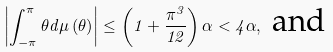Convert formula to latex. <formula><loc_0><loc_0><loc_500><loc_500>\left | \int _ { - \pi } ^ { \pi } \theta d \mu \left ( \theta \right ) \right | \leq \left ( 1 + \frac { \pi ^ { 3 } } { 1 2 } \right ) \alpha < 4 \alpha , \text { and}</formula> 